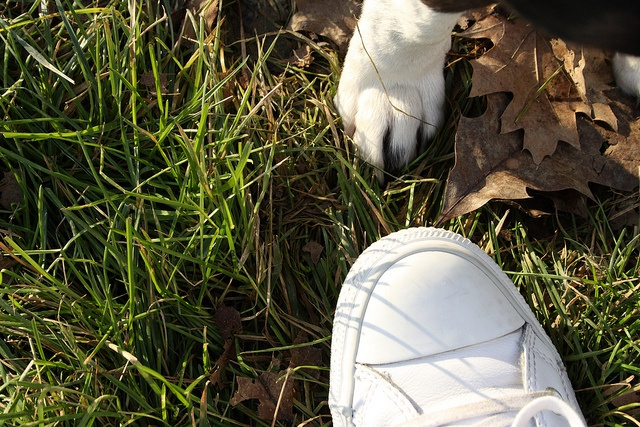Describe the objects in this image and their specific colors. I can see a dog in black, ivory, darkgray, and gray tones in this image. 